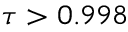Convert formula to latex. <formula><loc_0><loc_0><loc_500><loc_500>\tau > 0 . 9 9 8</formula> 